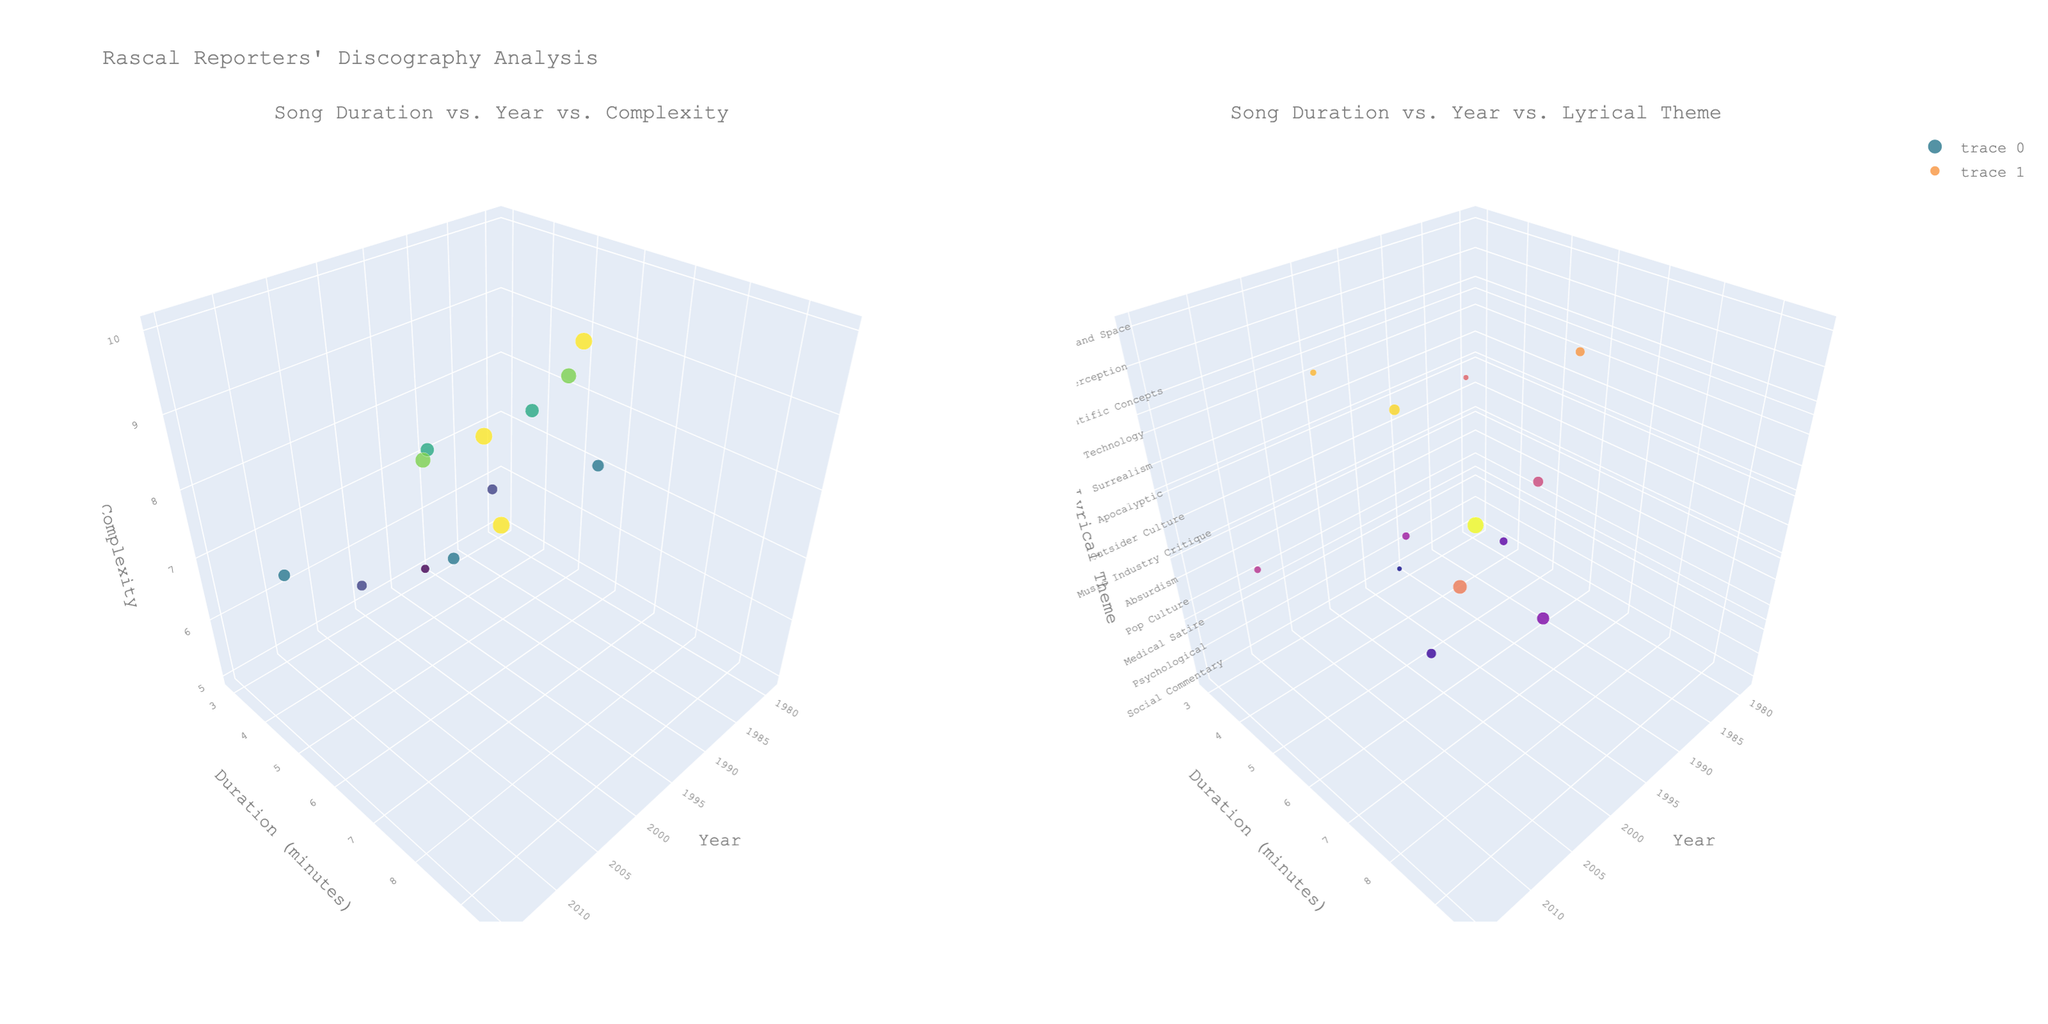What are the axes titles of the first 3D scatter plot? The first 3D scatter plot has three axes: x-axis labelled "Year," y-axis labelled "Duration (minutes)," and z-axis labelled "Complexity."
Answer: "Year," "Duration (minutes)," "Complexity" What is the general trend between song duration and release year in both 3D scatter plots? In both subplots, you can see that song durations vary over the years. Some years have longer durations, while others have shorter ones without a clear increasing or decreasing trend.
Answer: Varies Which song has the largest size marker in the first subplot and what does it represent? The song with the largest size marker is "Xenochronous Requiem," and it indicates that it has the highest complexity value of 10.
Answer: "Xenochronous Requiem" What's the color range used in the second subplot? The second subplot uses a Plasma colorscale to represent different lyrical themes, covering a range from dark to light colors.
Answer: Plasma colorscale, dark to light In which year did the song with the longest duration release, and what is the song's name? In the data, "Xenochronous Requiem" has the longest duration of 9.6 minutes and was released in the year 2015.
Answer: 2015, "Xenochronous Requiem" Compare the complexity between "The Great Annealing" and "Steve's Chickens." "The Great Annealing" has a complexity of 10, while "Steve's Chickens" has a complexity of 5.
Answer: "The Great Annealing" is more complex Which song clusters have shorter durations generally - high-complexity songs or low-complexity songs? Shorter durations appear more frequently among songs with lower complexity, as seen by smaller markers in the lower z-axis regions in the first subplot.
Answer: Low-complexity songs How are the "Medical Satire" and "Surrealism" themes differentiated in the second subplot's z-axis? The "Medical Satire" theme with the song "Bedside Manner" has a z-value of 2, while the "Surrealism" theme with the song "The Day the Egg Cracked" has a z-value of 5 in the second subplot.
Answer: "Medical Satire" (2), "Surrealism" (5) Is there any correlation between high-duration songs and their lyrical themes? High-duration songs like "Phosphene Holiday" and "Xenochronous Requiem" appear in various lyrical themes, indicating no strict correlation between duration and lyrical theme.
Answer: No strict correlation What is the range of years covered by Rascal Reporters' discography shown in the plots? The discography shown ranges from 1979 with "The Foul-Mouthed Wife of the Captain of Industry" to 2015 with "Xenochronous Requiem."
Answer: 1979 to 2015 